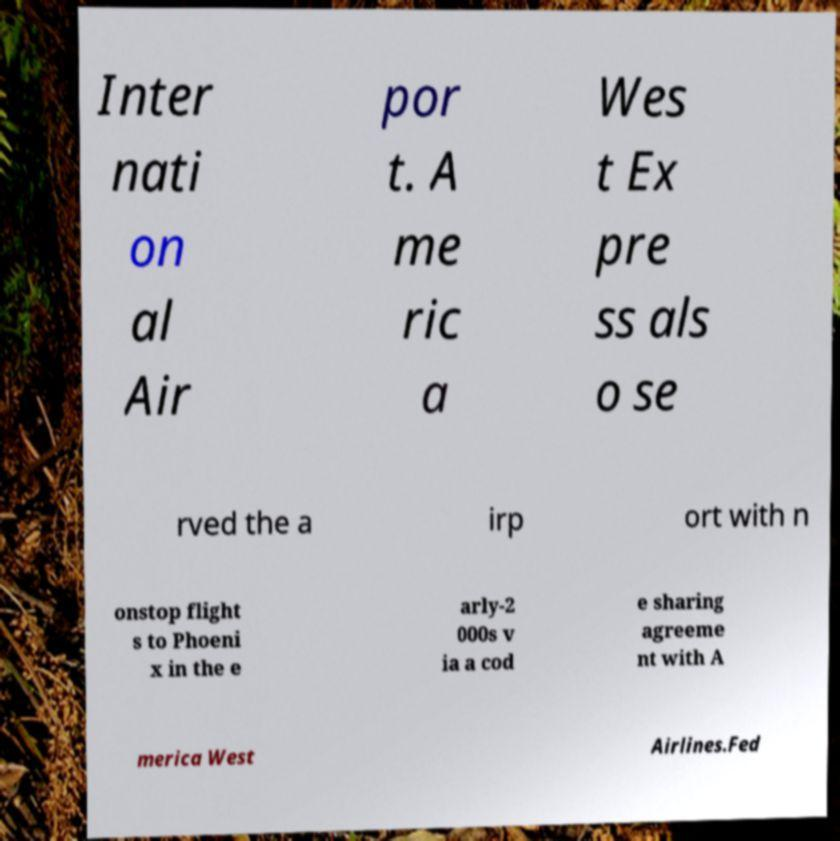There's text embedded in this image that I need extracted. Can you transcribe it verbatim? Inter nati on al Air por t. A me ric a Wes t Ex pre ss als o se rved the a irp ort with n onstop flight s to Phoeni x in the e arly-2 000s v ia a cod e sharing agreeme nt with A merica West Airlines.Fed 